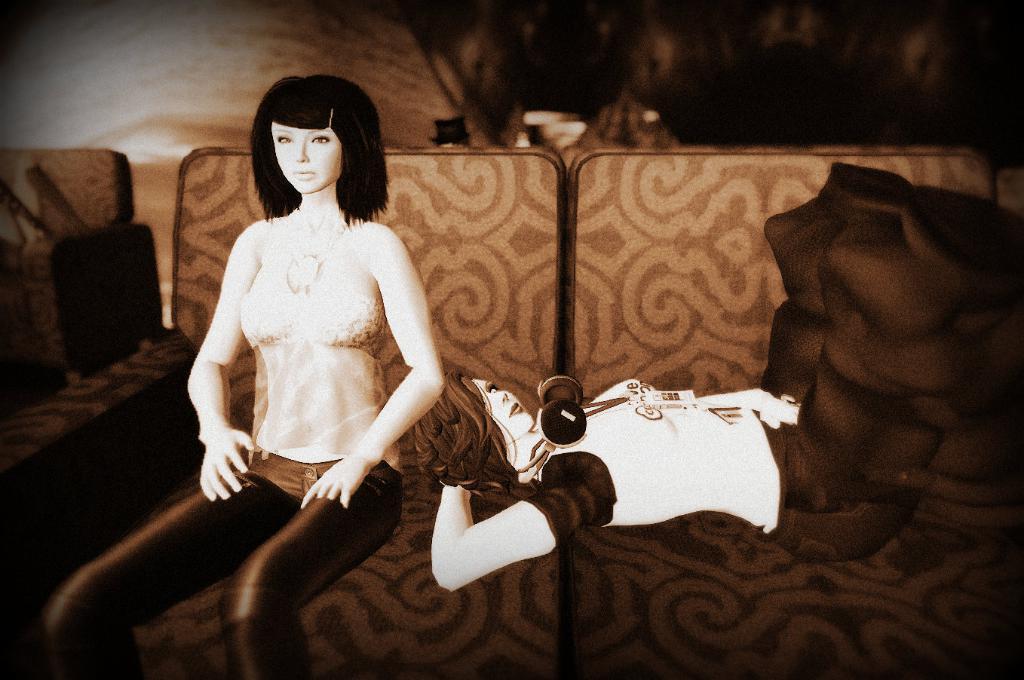In one or two sentences, can you explain what this image depicts? One woman is sitting on the couch and another woman is lying on the couch. Background it is blur. 